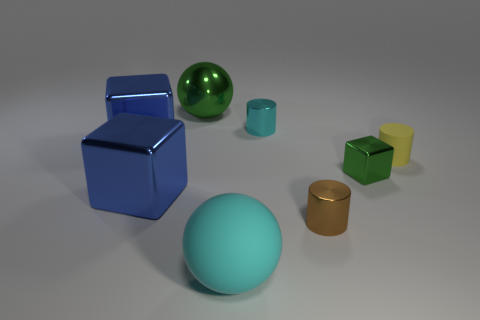Add 1 tiny metal cylinders. How many objects exist? 9 Subtract all spheres. How many objects are left? 6 Subtract 0 yellow spheres. How many objects are left? 8 Subtract all tiny green shiny blocks. Subtract all large cylinders. How many objects are left? 7 Add 1 blue objects. How many blue objects are left? 3 Add 7 large blue metallic cubes. How many large blue metallic cubes exist? 9 